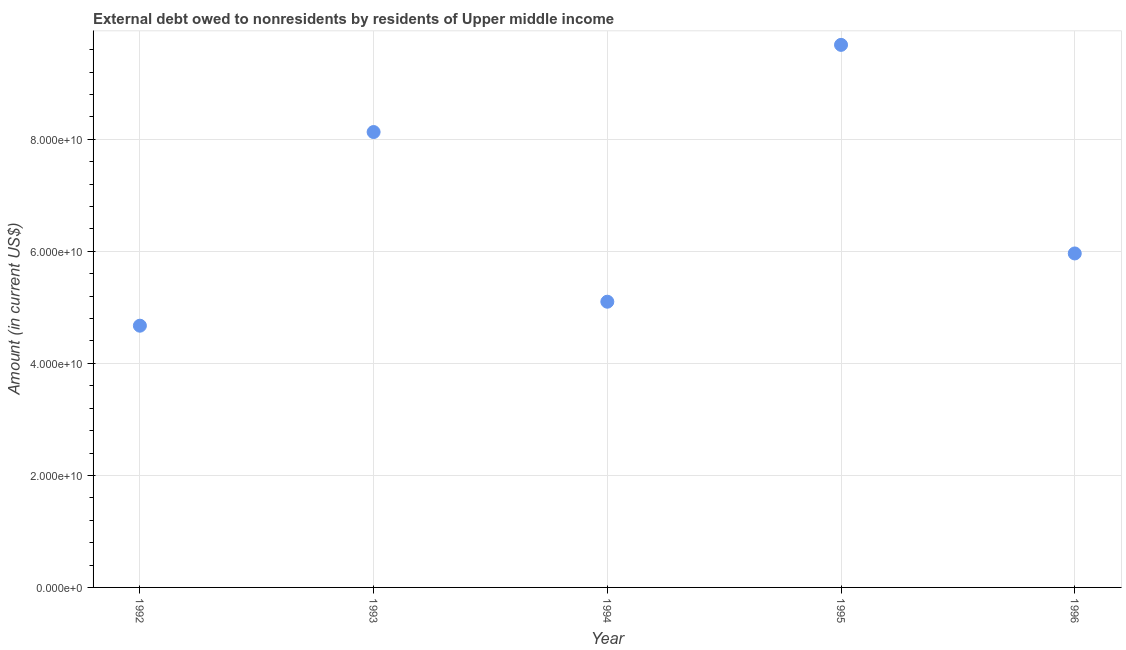What is the debt in 1993?
Your answer should be very brief. 8.13e+1. Across all years, what is the maximum debt?
Provide a short and direct response. 9.69e+1. Across all years, what is the minimum debt?
Keep it short and to the point. 4.67e+1. What is the sum of the debt?
Give a very brief answer. 3.36e+11. What is the difference between the debt in 1992 and 1993?
Your response must be concise. -3.46e+1. What is the average debt per year?
Keep it short and to the point. 6.71e+1. What is the median debt?
Give a very brief answer. 5.96e+1. In how many years, is the debt greater than 32000000000 US$?
Make the answer very short. 5. What is the ratio of the debt in 1993 to that in 1995?
Make the answer very short. 0.84. Is the difference between the debt in 1993 and 1995 greater than the difference between any two years?
Provide a short and direct response. No. What is the difference between the highest and the second highest debt?
Your answer should be very brief. 1.56e+1. Is the sum of the debt in 1993 and 1996 greater than the maximum debt across all years?
Your answer should be compact. Yes. What is the difference between the highest and the lowest debt?
Your answer should be compact. 5.01e+1. In how many years, is the debt greater than the average debt taken over all years?
Ensure brevity in your answer.  2. Does the debt monotonically increase over the years?
Offer a terse response. No. How many dotlines are there?
Your answer should be compact. 1. How many years are there in the graph?
Ensure brevity in your answer.  5. What is the difference between two consecutive major ticks on the Y-axis?
Make the answer very short. 2.00e+1. What is the title of the graph?
Give a very brief answer. External debt owed to nonresidents by residents of Upper middle income. What is the label or title of the Y-axis?
Your response must be concise. Amount (in current US$). What is the Amount (in current US$) in 1992?
Ensure brevity in your answer.  4.67e+1. What is the Amount (in current US$) in 1993?
Give a very brief answer. 8.13e+1. What is the Amount (in current US$) in 1994?
Your answer should be compact. 5.10e+1. What is the Amount (in current US$) in 1995?
Offer a terse response. 9.69e+1. What is the Amount (in current US$) in 1996?
Keep it short and to the point. 5.96e+1. What is the difference between the Amount (in current US$) in 1992 and 1993?
Your response must be concise. -3.46e+1. What is the difference between the Amount (in current US$) in 1992 and 1994?
Your answer should be compact. -4.28e+09. What is the difference between the Amount (in current US$) in 1992 and 1995?
Offer a terse response. -5.01e+1. What is the difference between the Amount (in current US$) in 1992 and 1996?
Your answer should be compact. -1.29e+1. What is the difference between the Amount (in current US$) in 1993 and 1994?
Your response must be concise. 3.03e+1. What is the difference between the Amount (in current US$) in 1993 and 1995?
Offer a very short reply. -1.56e+1. What is the difference between the Amount (in current US$) in 1993 and 1996?
Make the answer very short. 2.17e+1. What is the difference between the Amount (in current US$) in 1994 and 1995?
Offer a very short reply. -4.59e+1. What is the difference between the Amount (in current US$) in 1994 and 1996?
Keep it short and to the point. -8.62e+09. What is the difference between the Amount (in current US$) in 1995 and 1996?
Keep it short and to the point. 3.72e+1. What is the ratio of the Amount (in current US$) in 1992 to that in 1993?
Make the answer very short. 0.57. What is the ratio of the Amount (in current US$) in 1992 to that in 1994?
Your answer should be very brief. 0.92. What is the ratio of the Amount (in current US$) in 1992 to that in 1995?
Offer a terse response. 0.48. What is the ratio of the Amount (in current US$) in 1992 to that in 1996?
Keep it short and to the point. 0.78. What is the ratio of the Amount (in current US$) in 1993 to that in 1994?
Give a very brief answer. 1.59. What is the ratio of the Amount (in current US$) in 1993 to that in 1995?
Your answer should be compact. 0.84. What is the ratio of the Amount (in current US$) in 1993 to that in 1996?
Give a very brief answer. 1.36. What is the ratio of the Amount (in current US$) in 1994 to that in 1995?
Make the answer very short. 0.53. What is the ratio of the Amount (in current US$) in 1994 to that in 1996?
Give a very brief answer. 0.85. What is the ratio of the Amount (in current US$) in 1995 to that in 1996?
Offer a very short reply. 1.62. 